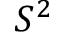Convert formula to latex. <formula><loc_0><loc_0><loc_500><loc_500>S ^ { 2 }</formula> 